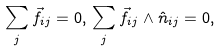<formula> <loc_0><loc_0><loc_500><loc_500>\sum _ { j } \vec { f } _ { i j } = 0 , \, \sum _ { j } \vec { f } _ { i j } \wedge \hat { n } _ { i j } = 0 ,</formula> 